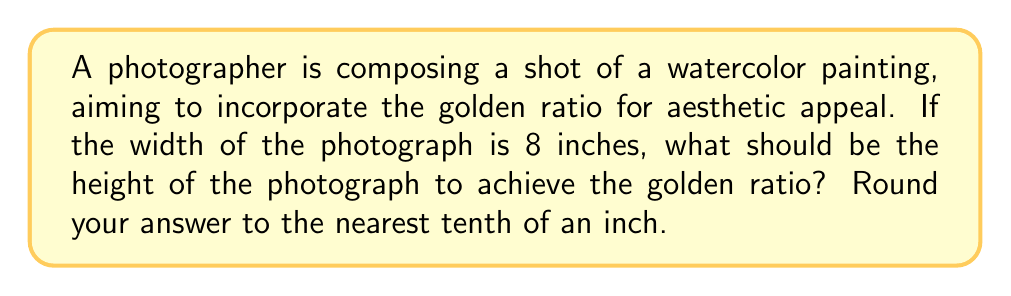Provide a solution to this math problem. To solve this problem, we need to understand and apply the concept of the golden ratio in photographic composition.

1) The golden ratio, denoted by φ (phi), is approximately equal to 1.618033988749895.

2) In a rectangle with the golden ratio, the ratio of the longer side to the shorter side is equal to φ.

3) Let's denote the width as w and the height as h. We know that w = 8 inches.

4) The golden ratio states that:
   $$\frac{\text{longer side}}{\text{shorter side}} = φ$$

5) In this case, we assume the height is longer than the width:
   $$\frac{h}{w} = φ$$

6) Substituting the known values:
   $$\frac{h}{8} = 1.618033988749895$$

7) To solve for h, multiply both sides by 8:
   $$h = 8 * 1.618033988749895$$

8) Calculate:
   $$h = 12.94427191$$

9) Rounding to the nearest tenth:
   $$h ≈ 12.9 \text{ inches}$$

Therefore, the height of the photograph should be approximately 12.9 inches to achieve the golden ratio with a width of 8 inches.
Answer: 12.9 inches 